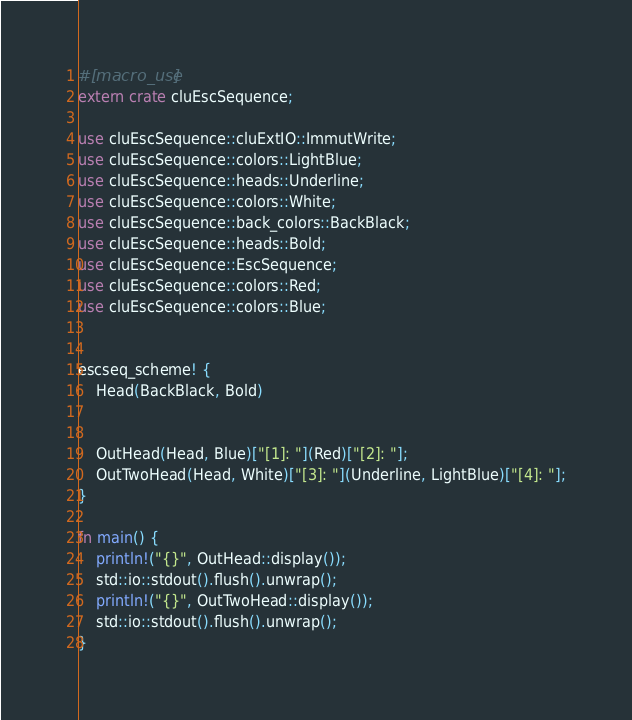<code> <loc_0><loc_0><loc_500><loc_500><_Rust_>
#[macro_use]
extern crate cluEscSequence;

use cluEscSequence::cluExtIO::ImmutWrite;
use cluEscSequence::colors::LightBlue;
use cluEscSequence::heads::Underline;
use cluEscSequence::colors::White;
use cluEscSequence::back_colors::BackBlack;
use cluEscSequence::heads::Bold;
use cluEscSequence::EscSequence;
use cluEscSequence::colors::Red;
use cluEscSequence::colors::Blue;


escseq_scheme! {
	Head(BackBlack, Bold)
	
	
	OutHead(Head, Blue)["[1]: "](Red)["[2]: "];
	OutTwoHead(Head, White)["[3]: "](Underline, LightBlue)["[4]: "];
}

fn main() {
	println!("{}", OutHead::display());
	std::io::stdout().flush().unwrap();
	println!("{}", OutTwoHead::display());
	std::io::stdout().flush().unwrap();
}


</code> 